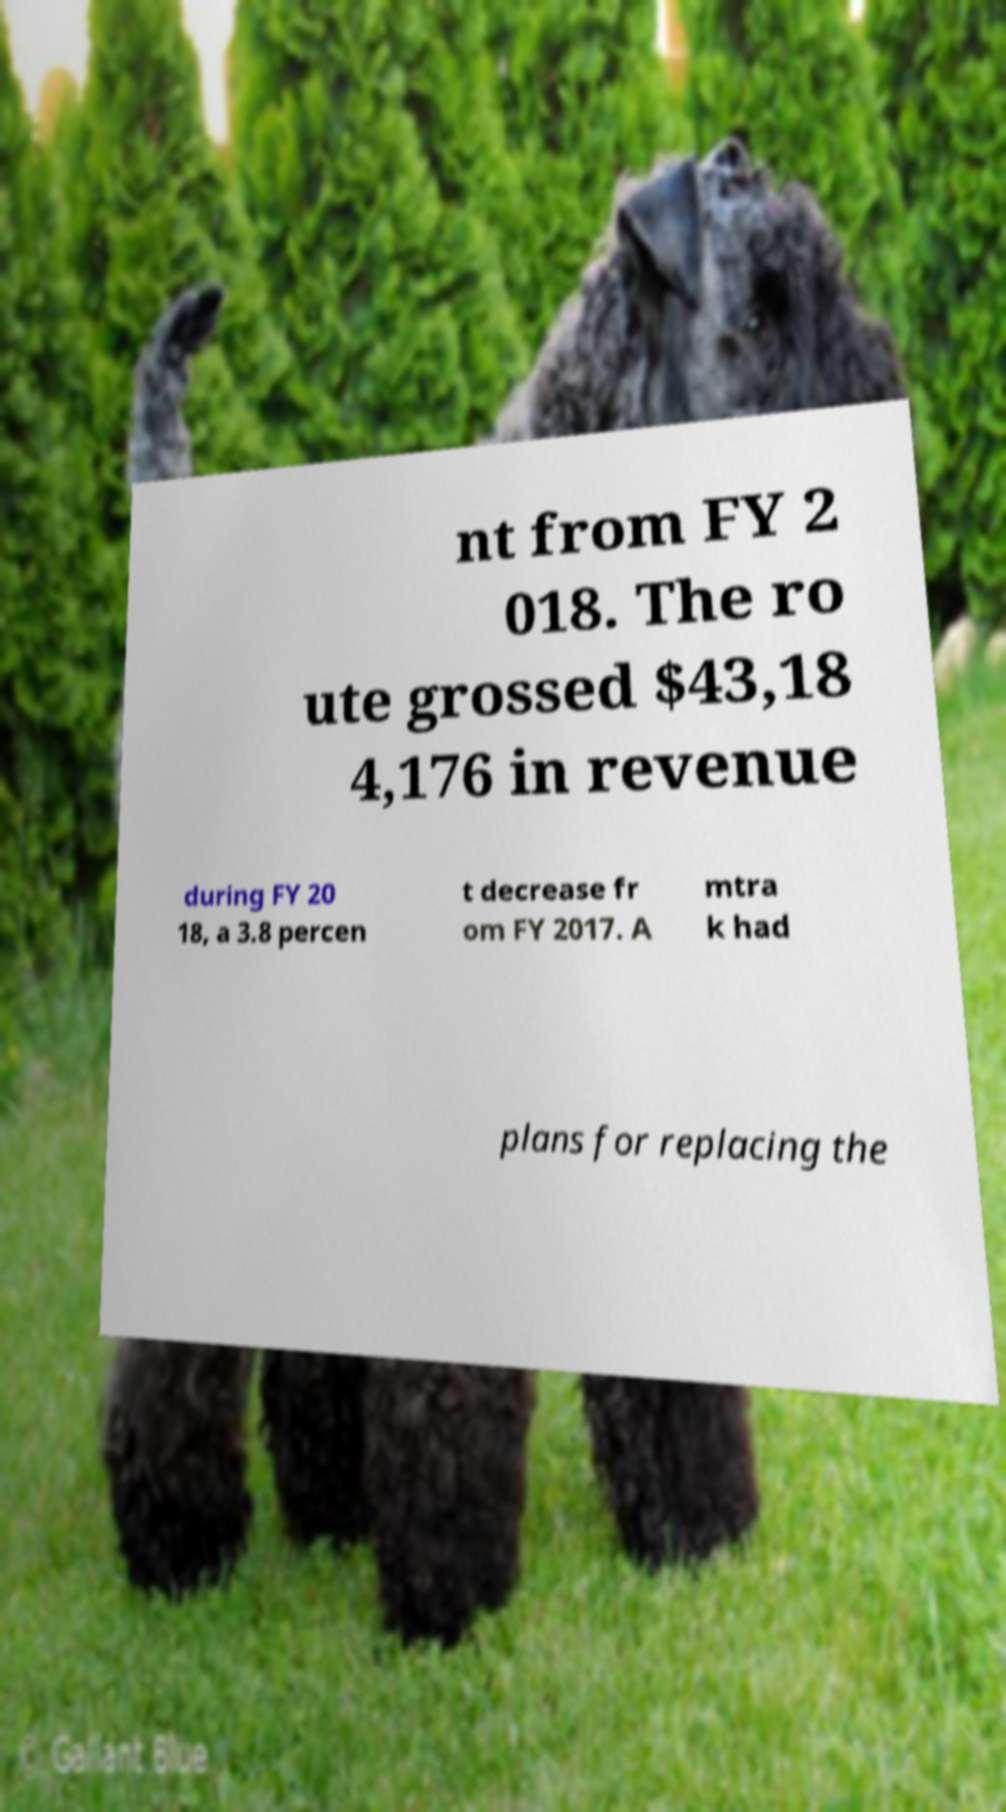There's text embedded in this image that I need extracted. Can you transcribe it verbatim? nt from FY 2 018. The ro ute grossed $43,18 4,176 in revenue during FY 20 18, a 3.8 percen t decrease fr om FY 2017. A mtra k had plans for replacing the 